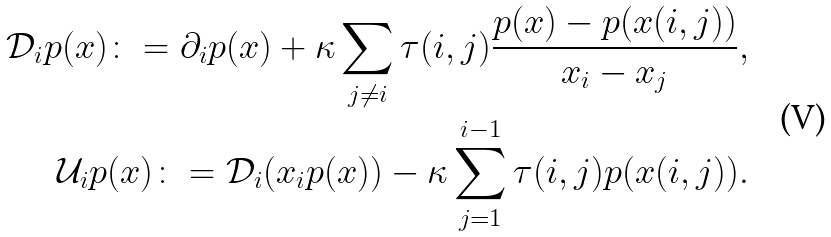Convert formula to latex. <formula><loc_0><loc_0><loc_500><loc_500>\mathcal { D } _ { i } p ( x ) \colon = \partial _ { i } p ( x ) + \kappa \sum _ { j \neq i } \tau ( i , j ) \frac { p ( x ) - p ( x ( i , j ) ) } { x _ { i } - x _ { j } } , \\ \mathcal { U } _ { i } p ( x ) \colon = \mathcal { D } _ { i } ( x _ { i } p ( x ) ) - \kappa \sum _ { j = 1 } ^ { i - 1 } \tau ( i , j ) p ( x ( i , j ) ) .</formula> 